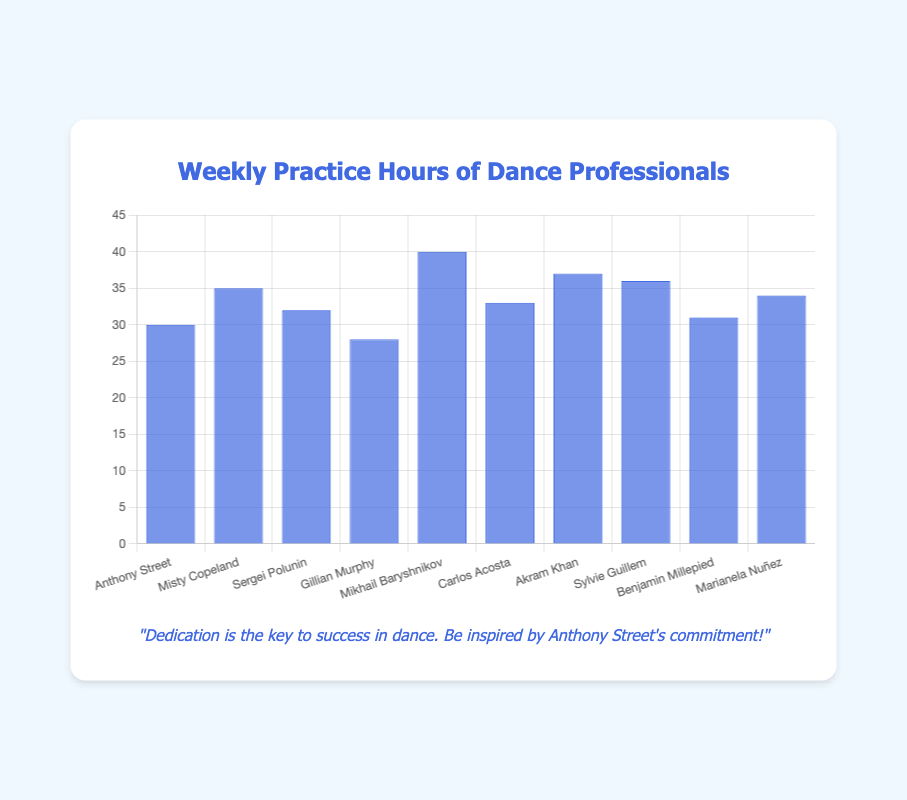Which dance professional practices the most hours a week? By looking at the heights of the bars, Mikhail Baryshnikov’s bar is the tallest at 40 hours, indicating he practices the most hours a week.
Answer: Mikhail Baryshnikov How many hours a week do Anthony Street and Misty Copeland practice in total? To find the total weekly hours, add Anthony Street’s 30 hours to Misty Copeland’s 35 hours, which equals 65 hours.
Answer: 65 Who practices more hours, Sylvie Guillem or Sergei Polunin? Comparing their bars, Sylvie Guillem practices 36 hours, which is more than Sergei Polunin's 32 hours.
Answer: Sylvie Guillem What is the average weekly practice hours of Marianela Nuñez, Carlos Acosta, and Akram Khan? Add the hours of Marianela Nuñez (34), Carlos Acosta (33), and Akram Khan (37), which totals 104 hours, then divide by 3. The average is approximately 34.67 hours.
Answer: 34.67 How much more does Misty Copeland practice compared to Gillian Murphy? Misty Copeland practices 35 hours and Gillian Murphy practices 28 hours, so Misty practices 7 hours more.
Answer: 7 Which dance professional practices the least hours a week? By comparing the heights of all the bars, Gillian Murphy’s bar is the shortest at 28 hours, indicating she practices the least.
Answer: Gillian Murphy Group Anthony Street, Mikhail Baryshnikov, and Akram Khan. What is their total practice time? Adding their practice hours: Anthony Street (30), Mikhail Baryshnikov (40), and Akram Khan (37), the total is 107 hours.
Answer: 107 Which two dance professionals practice a cumulative 69 hours per week? Search for pairs whose hours sum to 69. Sergei Polunin (32) and Benjamin Millepied (31) combine to 63, but Carlos Acosta (33) and Marianela Nuñez (34) together practice 67 hours. The correct pair, Sylvie Guillem (36) and Anthony Street (30), together total 66 hours, no combination giving exactly 69.
Answer: No exact match What is the median weekly practice hours of all the dance professionals? Arrange all the numbers in ascending order: 28, 30, 31, 32, 33, 34, 35, 36, 37, 40. The middle two numbers are 33 and 34; their average gives the median, which is 33.5.
Answer: 33.5 